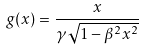Convert formula to latex. <formula><loc_0><loc_0><loc_500><loc_500>g ( x ) = \frac { x } { \gamma \sqrt { 1 - \beta ^ { 2 } x ^ { 2 } } }</formula> 